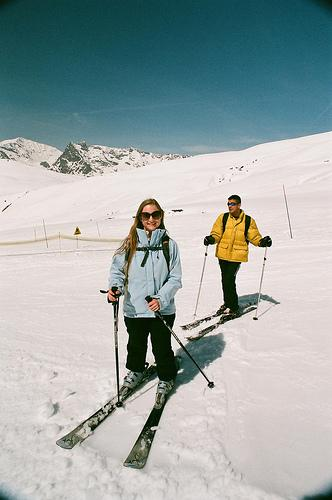Point out the most eye-catching elements in the image. Two people on skis stand out, sporting a vivid blue jacket for the girl and a striking yellow jacket for the boy. Moreover, the mountains in the distance and clear blue sky provide an impressive backdrop. Perform a visual entailment task, and complete the phrase: "There is a..." There is a clear sky with no clouds, providing excellent skiing conditions for the girl in the blue jacket and the boy in the yellow jacket. Write a brief advertisement for a ski resort featuring this image. Experience the adventure of a lifetime at our ski resort! Join fellow skiers, like the girl in the blue jacket and the boy in the yellow jacket, as they conquer the magnificent slopes. Enjoy breathtaking panoramic views of the mountains and the captivating cloudless sky. Book now and make unforgettable memories! Respond in the style of an AI providing quick answers to a user's question about the image. There are two skiers (girl in blue jacket, boy in yellow jacket), mountains, clear sky, and a yellow sign within the image. Act as a knowledgeable guide on a multi-choice VQA task, and answer: What is observed on the girl's face that protects her eyes? The girl is wearing round sunglasses to protect her eyes from the sun's glare. Using verbose language, describe the scene featuring both skiers and their attire. The picturesque scene showcases a splendid duo of ski enthusiasts gracefully gliding down the snow-covered landscape. The female is garbed in a vibrant blue jacket, whilst her male counterpart is adorned in an eye-catching yellow one. Both individuals protect their eyes from the sun's glare with chic sunglasses. Engage in a referential expression grounding task by explaining what "her skis" refers to in the image. "Her skis" refers to the black skis in the snow that belong to the girl in the blue jacket who is skiing in the image. Imagine this is a part of a poem, convey the essence of the scene using figurative language. A yellow sign stands sentinel amongst a snow-covered page. In a casual conversational tone, give a general description of the image focusing on the people, their clothing, and the environment. Yo, there are two people skiing, a girl in a blue jacket and a boy in a yellow jacket. Both of them are wearing sunglasses. They're on a snowy mountain with a clear sky and some mountains in the distance. There's also a yellow sign nearby. Pretend you are a radio commentator giving a quick update on what is happening in this image. Reporting live! We have an exciting scene here today with a young girl and boy skiing down the slopes, each wearing colorful jackets and sunglasses. The weather looks perfect with mountains in the distance and not a cloud in the sky! 